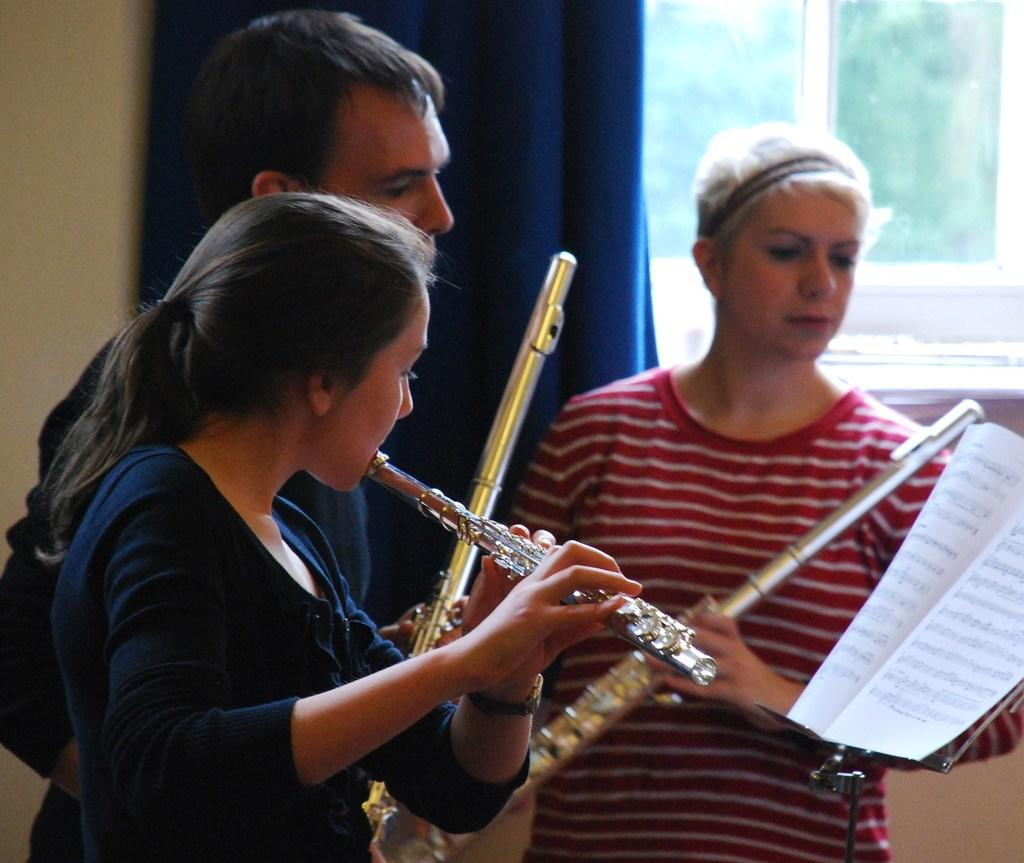How many people are in the image? There are two women and a man in the image. What is the woman in the black dress wearing? The woman in the black dress is wearing a black dress. What is the woman in the black dress doing? The woman in the black dress is playing a musical instrument. What are the other two people in the image doing? The other woman and the man are holding musical instruments. What type of heart-shaped cart can be seen in the image? There is no heart-shaped cart present in the image. What kind of feast is being prepared by the people in the image? There is no indication of a feast or any food preparation in the image. 